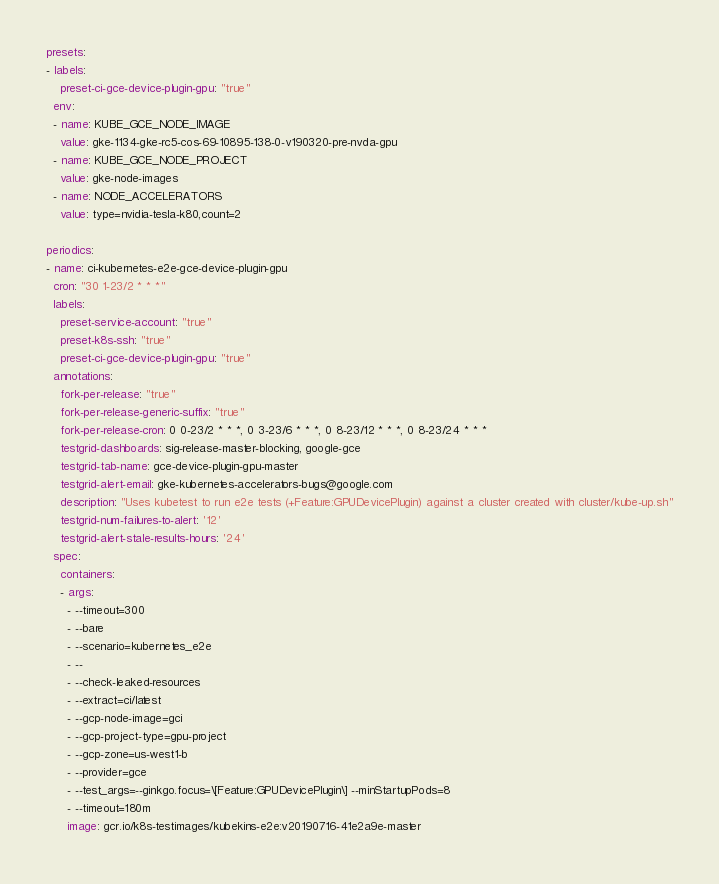<code> <loc_0><loc_0><loc_500><loc_500><_YAML_>presets:
- labels:
    preset-ci-gce-device-plugin-gpu: "true"
  env:
  - name: KUBE_GCE_NODE_IMAGE
    value: gke-1134-gke-rc5-cos-69-10895-138-0-v190320-pre-nvda-gpu
  - name: KUBE_GCE_NODE_PROJECT
    value: gke-node-images
  - name: NODE_ACCELERATORS
    value: type=nvidia-tesla-k80,count=2

periodics:
- name: ci-kubernetes-e2e-gce-device-plugin-gpu
  cron: "30 1-23/2 * * *"
  labels:
    preset-service-account: "true"
    preset-k8s-ssh: "true"
    preset-ci-gce-device-plugin-gpu: "true"
  annotations:
    fork-per-release: "true"
    fork-per-release-generic-suffix: "true"
    fork-per-release-cron: 0 0-23/2 * * *, 0 3-23/6 * * *, 0 8-23/12 * * *, 0 8-23/24 * * *
    testgrid-dashboards: sig-release-master-blocking, google-gce
    testgrid-tab-name: gce-device-plugin-gpu-master
    testgrid-alert-email: gke-kubernetes-accelerators-bugs@google.com
    description: "Uses kubetest to run e2e tests (+Feature:GPUDevicePlugin) against a cluster created with cluster/kube-up.sh"
    testgrid-num-failures-to-alert: '12'
    testgrid-alert-stale-results-hours: '24'
  spec:
    containers:
    - args:
      - --timeout=300
      - --bare
      - --scenario=kubernetes_e2e
      - --
      - --check-leaked-resources
      - --extract=ci/latest
      - --gcp-node-image=gci
      - --gcp-project-type=gpu-project
      - --gcp-zone=us-west1-b
      - --provider=gce
      - --test_args=--ginkgo.focus=\[Feature:GPUDevicePlugin\] --minStartupPods=8
      - --timeout=180m
      image: gcr.io/k8s-testimages/kubekins-e2e:v20190716-41e2a9e-master
</code> 